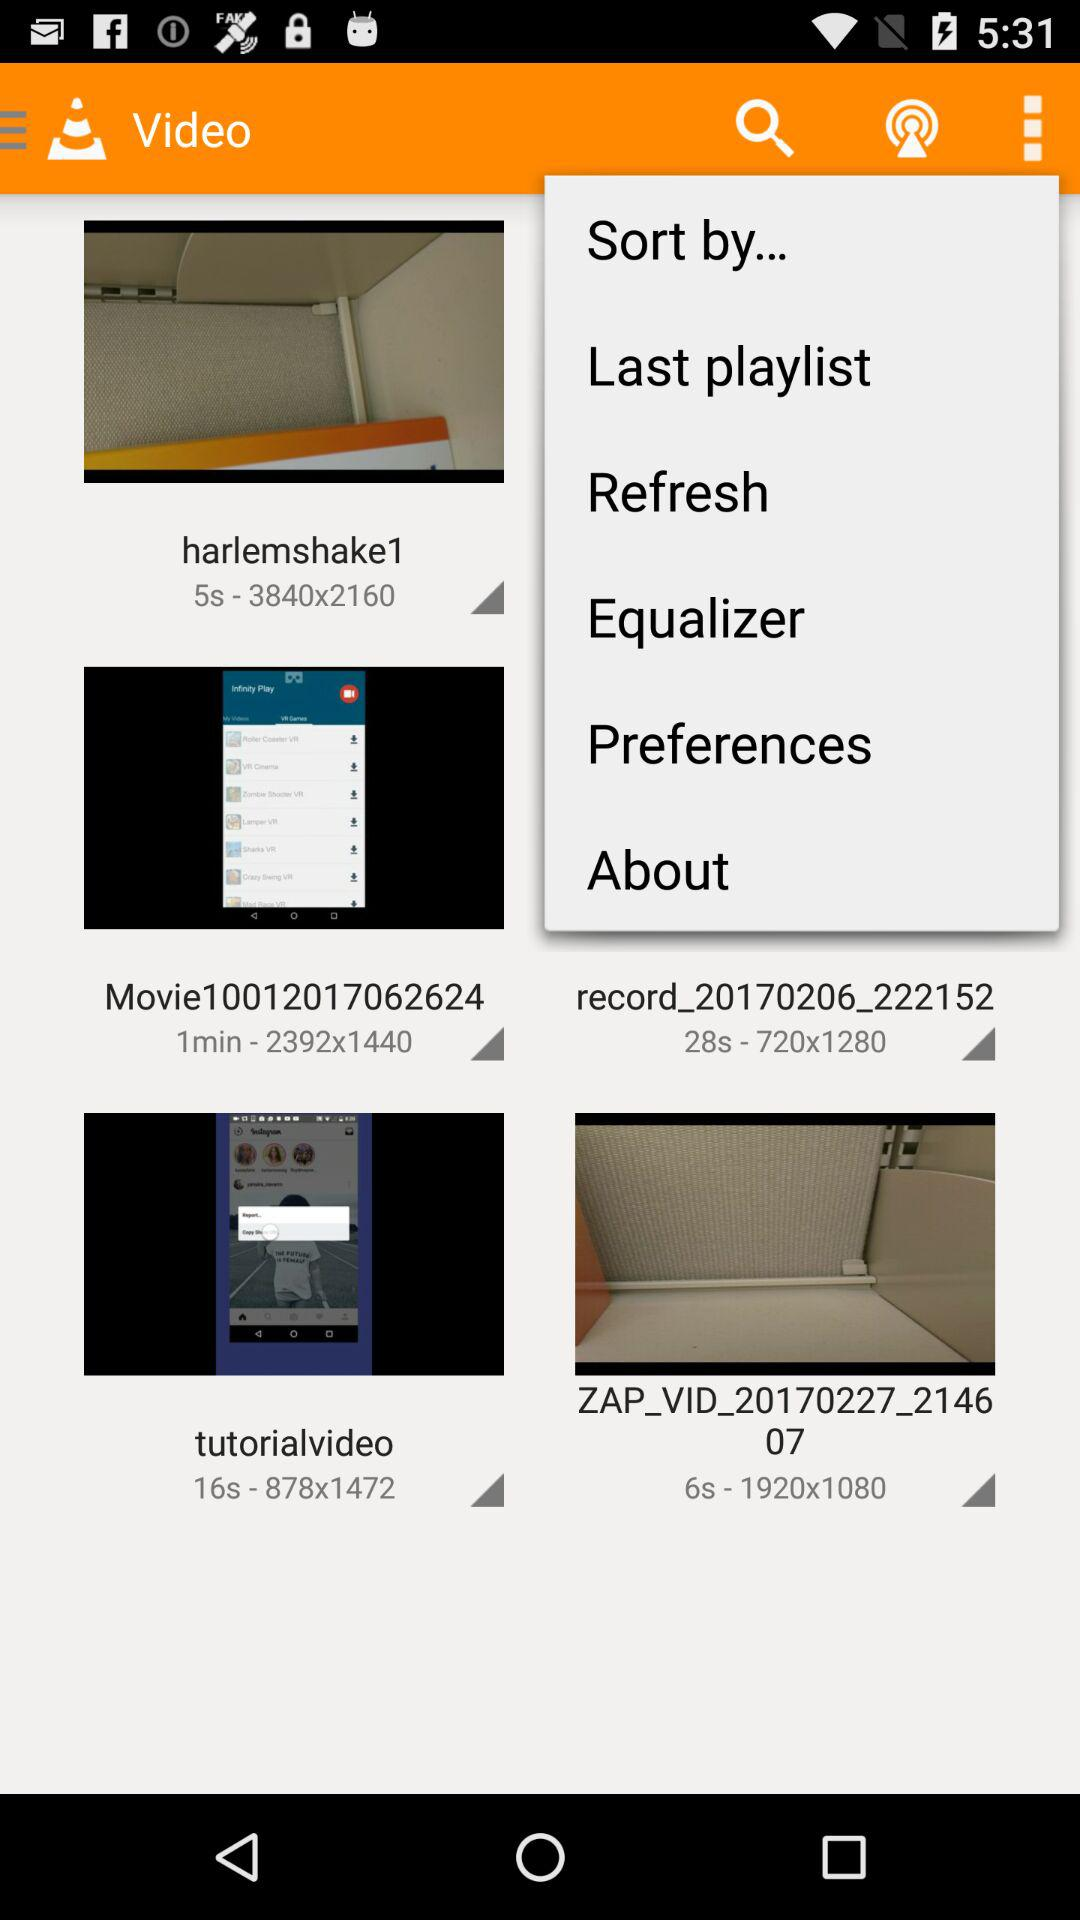How long is the "harlemshake1" video? The video is 5 seconds long. 